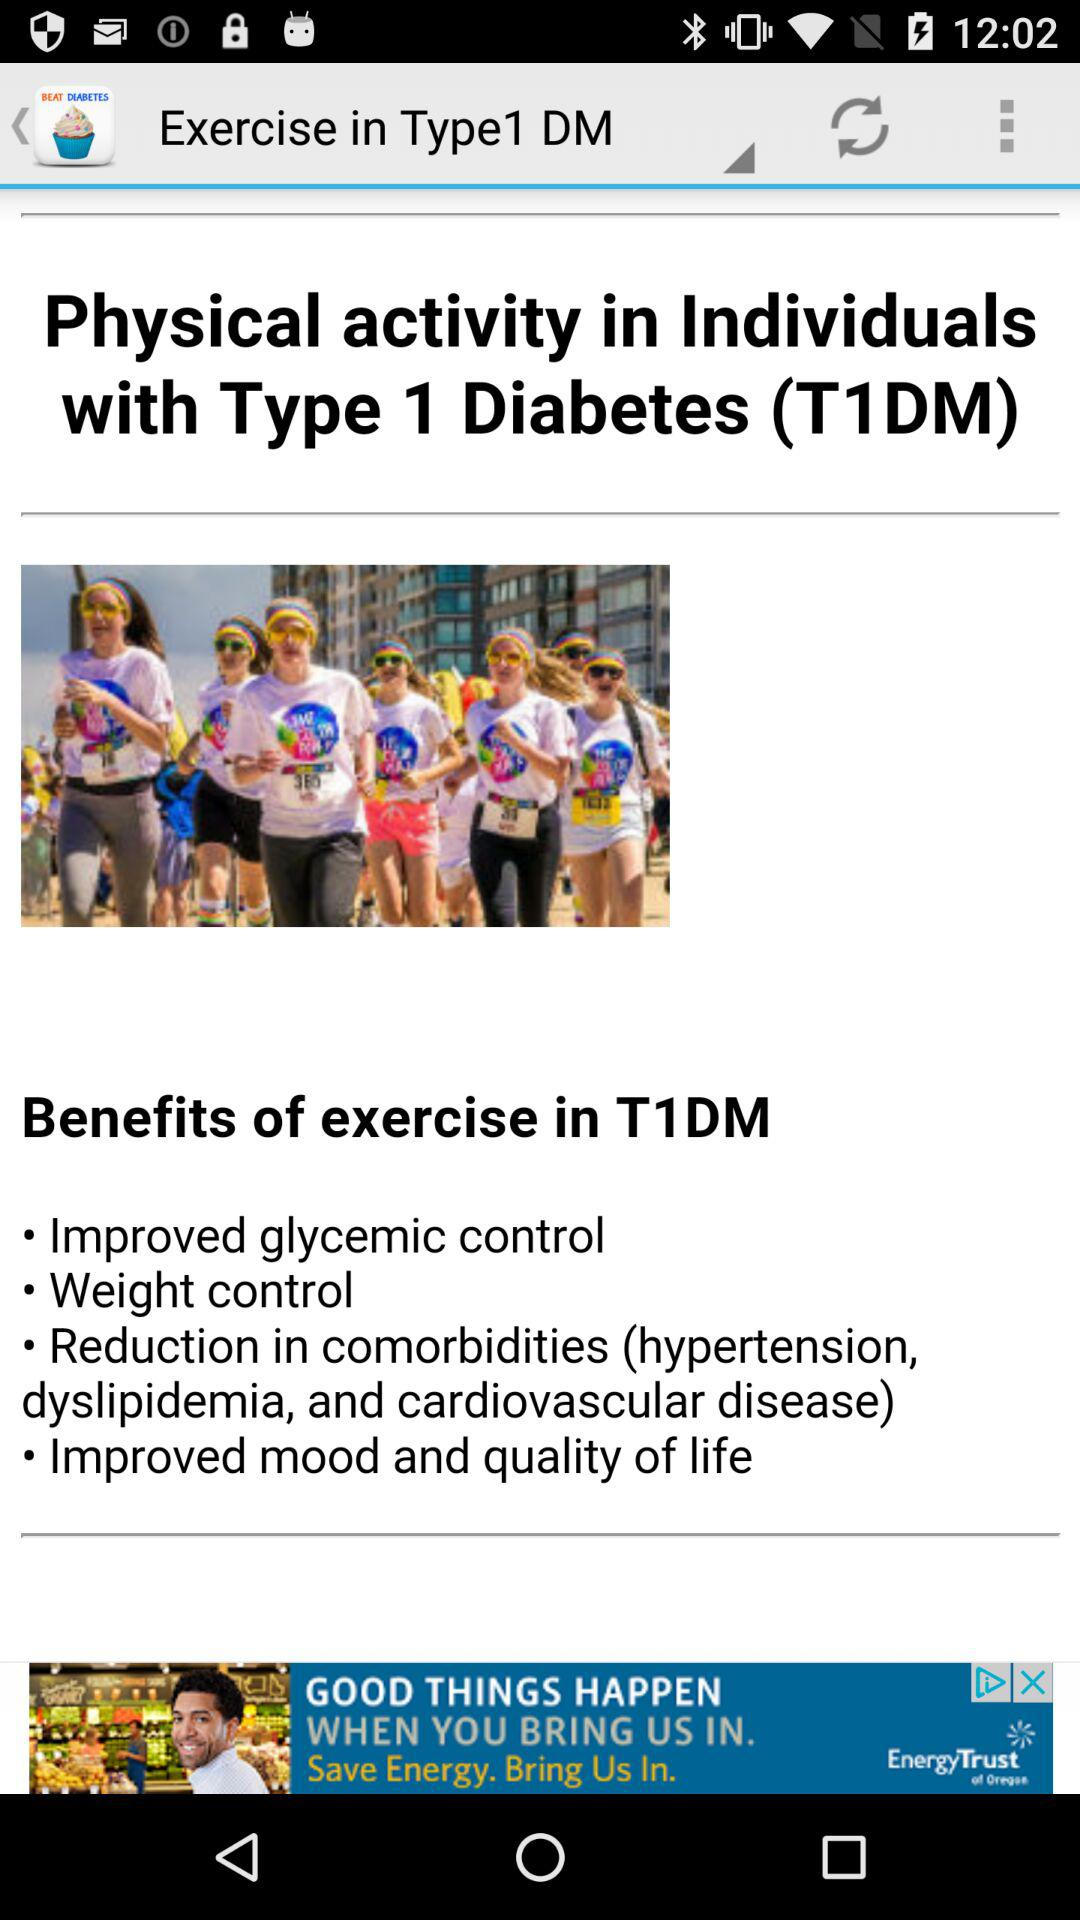What are the benefits of exercise for people with type 1 diabetes? The benefits of exercise are: "Improved glycemic control", "Weight control", "Reduction in comorbidities (hypertension, dyslipidemia, and cardiovascular disease)", and "Improved mood and quality of life". 